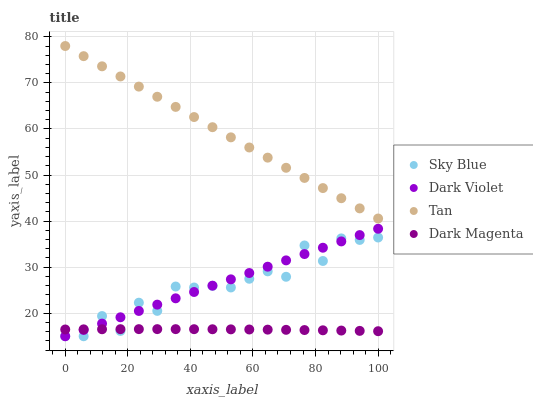Does Dark Magenta have the minimum area under the curve?
Answer yes or no. Yes. Does Tan have the maximum area under the curve?
Answer yes or no. Yes. Does Tan have the minimum area under the curve?
Answer yes or no. No. Does Dark Magenta have the maximum area under the curve?
Answer yes or no. No. Is Dark Violet the smoothest?
Answer yes or no. Yes. Is Sky Blue the roughest?
Answer yes or no. Yes. Is Tan the smoothest?
Answer yes or no. No. Is Tan the roughest?
Answer yes or no. No. Does Sky Blue have the lowest value?
Answer yes or no. Yes. Does Dark Magenta have the lowest value?
Answer yes or no. No. Does Tan have the highest value?
Answer yes or no. Yes. Does Dark Magenta have the highest value?
Answer yes or no. No. Is Dark Violet less than Tan?
Answer yes or no. Yes. Is Tan greater than Dark Violet?
Answer yes or no. Yes. Does Sky Blue intersect Dark Magenta?
Answer yes or no. Yes. Is Sky Blue less than Dark Magenta?
Answer yes or no. No. Is Sky Blue greater than Dark Magenta?
Answer yes or no. No. Does Dark Violet intersect Tan?
Answer yes or no. No. 